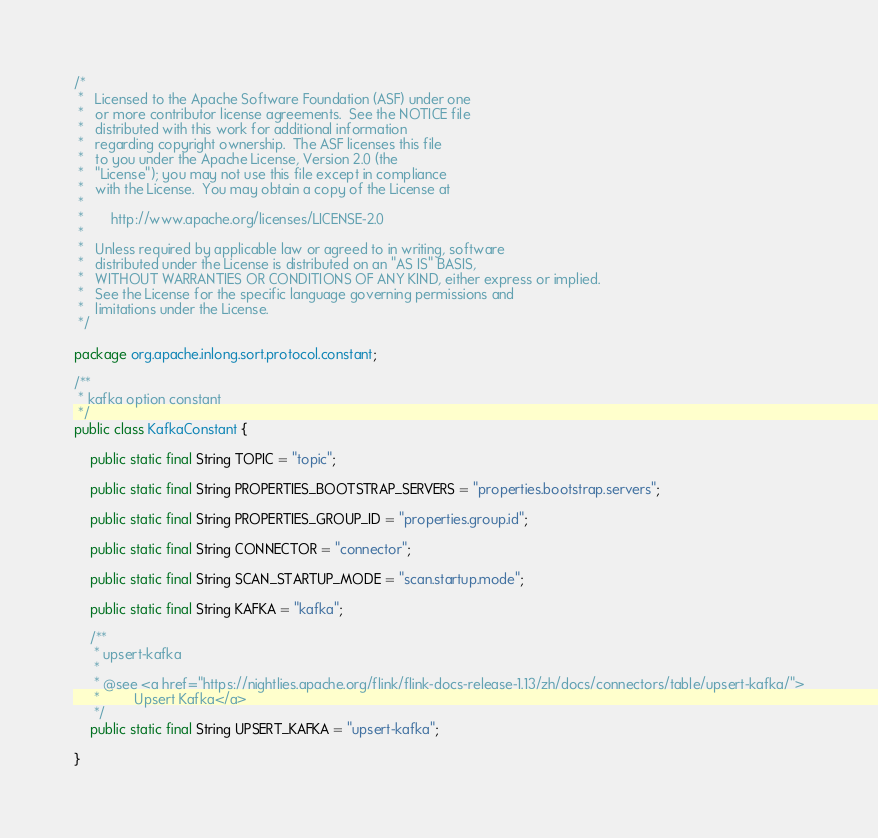Convert code to text. <code><loc_0><loc_0><loc_500><loc_500><_Java_>/*
 *   Licensed to the Apache Software Foundation (ASF) under one
 *   or more contributor license agreements.  See the NOTICE file
 *   distributed with this work for additional information
 *   regarding copyright ownership.  The ASF licenses this file
 *   to you under the Apache License, Version 2.0 (the
 *   "License"); you may not use this file except in compliance
 *   with the License.  You may obtain a copy of the License at
 *
 *       http://www.apache.org/licenses/LICENSE-2.0
 *
 *   Unless required by applicable law or agreed to in writing, software
 *   distributed under the License is distributed on an "AS IS" BASIS,
 *   WITHOUT WARRANTIES OR CONDITIONS OF ANY KIND, either express or implied.
 *   See the License for the specific language governing permissions and
 *   limitations under the License.
 */

package org.apache.inlong.sort.protocol.constant;

/**
 * kafka option constant
 */
public class KafkaConstant {

    public static final String TOPIC = "topic";

    public static final String PROPERTIES_BOOTSTRAP_SERVERS = "properties.bootstrap.servers";

    public static final String PROPERTIES_GROUP_ID = "properties.group.id";

    public static final String CONNECTOR = "connector";

    public static final String SCAN_STARTUP_MODE = "scan.startup.mode";

    public static final String KAFKA = "kafka";

    /**
     * upsert-kafka
     * 
     * @see <a href="https://nightlies.apache.org/flink/flink-docs-release-1.13/zh/docs/connectors/table/upsert-kafka/">
     *         Upsert Kafka</a>
     */
    public static final String UPSERT_KAFKA = "upsert-kafka";

}
</code> 